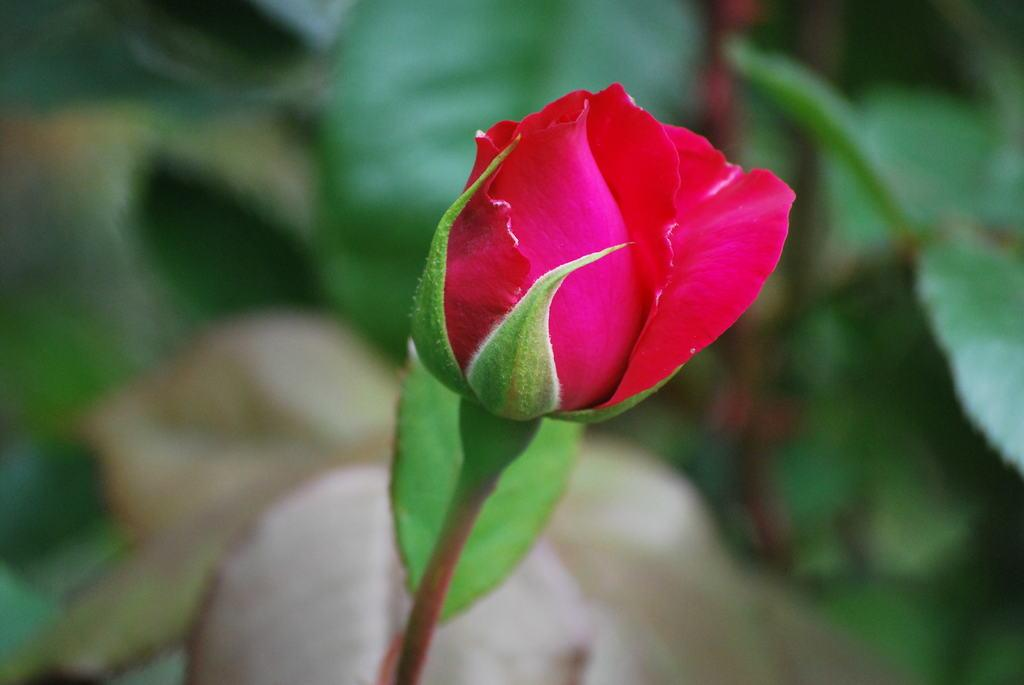What type of flower is in the image? There is a rose in the image. Can you describe the background of the image? The background of the image is blurred. What type of fruit is on the stove in the image? There is no fruit or stove present in the image; it only features a rose with a blurred background. 